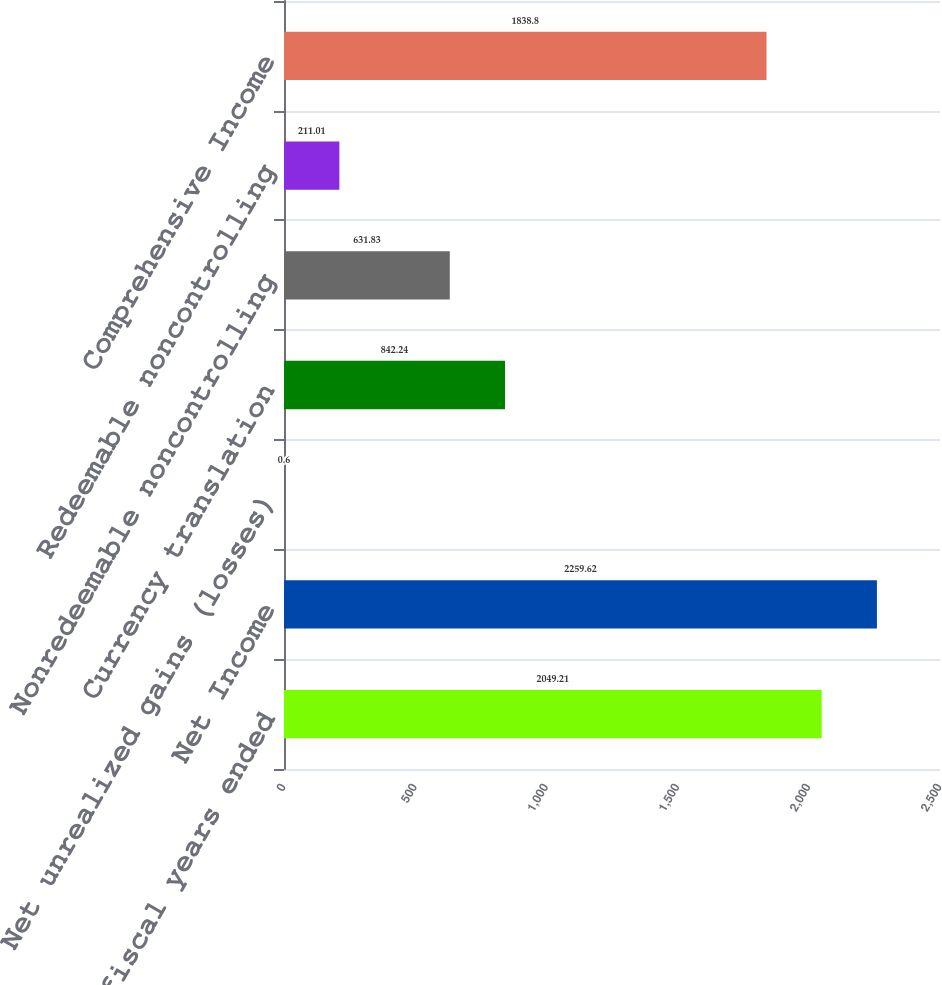Convert chart. <chart><loc_0><loc_0><loc_500><loc_500><bar_chart><fcel>for the fiscal years ended<fcel>Net Income<fcel>Net unrealized gains (losses)<fcel>Currency translation<fcel>Nonredeemable noncontrolling<fcel>Redeemable noncontrolling<fcel>Comprehensive Income<nl><fcel>2049.21<fcel>2259.62<fcel>0.6<fcel>842.24<fcel>631.83<fcel>211.01<fcel>1838.8<nl></chart> 